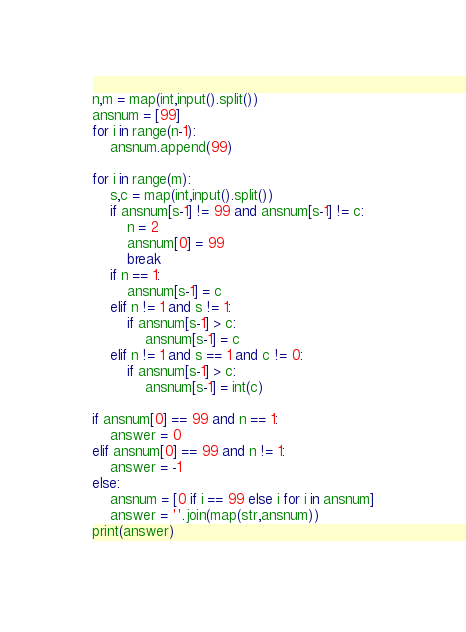<code> <loc_0><loc_0><loc_500><loc_500><_Python_>n,m = map(int,input().split())
ansnum = [99]
for i in range(n-1):
	ansnum.append(99)

for i in range(m):
	s,c = map(int,input().split())
	if ansnum[s-1] != 99 and ansnum[s-1] != c:
		n = 2
		ansnum[0] = 99
		break
	if n == 1:
		ansnum[s-1] = c
	elif n != 1 and s != 1:
		if ansnum[s-1] > c:
			ansnum[s-1] = c
	elif n != 1 and s == 1 and c != 0:
		if ansnum[s-1] > c:
			ansnum[s-1] = int(c)

if ansnum[0] == 99 and n == 1:
	answer = 0
elif ansnum[0] == 99 and n != 1:
	answer = -1
else:
	ansnum = [0 if i == 99 else i for i in ansnum]
	answer = ''.join(map(str,ansnum))
print(answer)</code> 